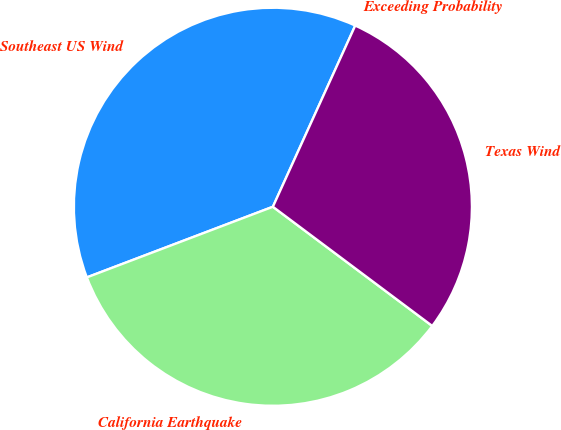<chart> <loc_0><loc_0><loc_500><loc_500><pie_chart><fcel>Exceeding Probability<fcel>Southeast US Wind<fcel>California Earthquake<fcel>Texas Wind<nl><fcel>0.0%<fcel>37.56%<fcel>34.0%<fcel>28.43%<nl></chart> 